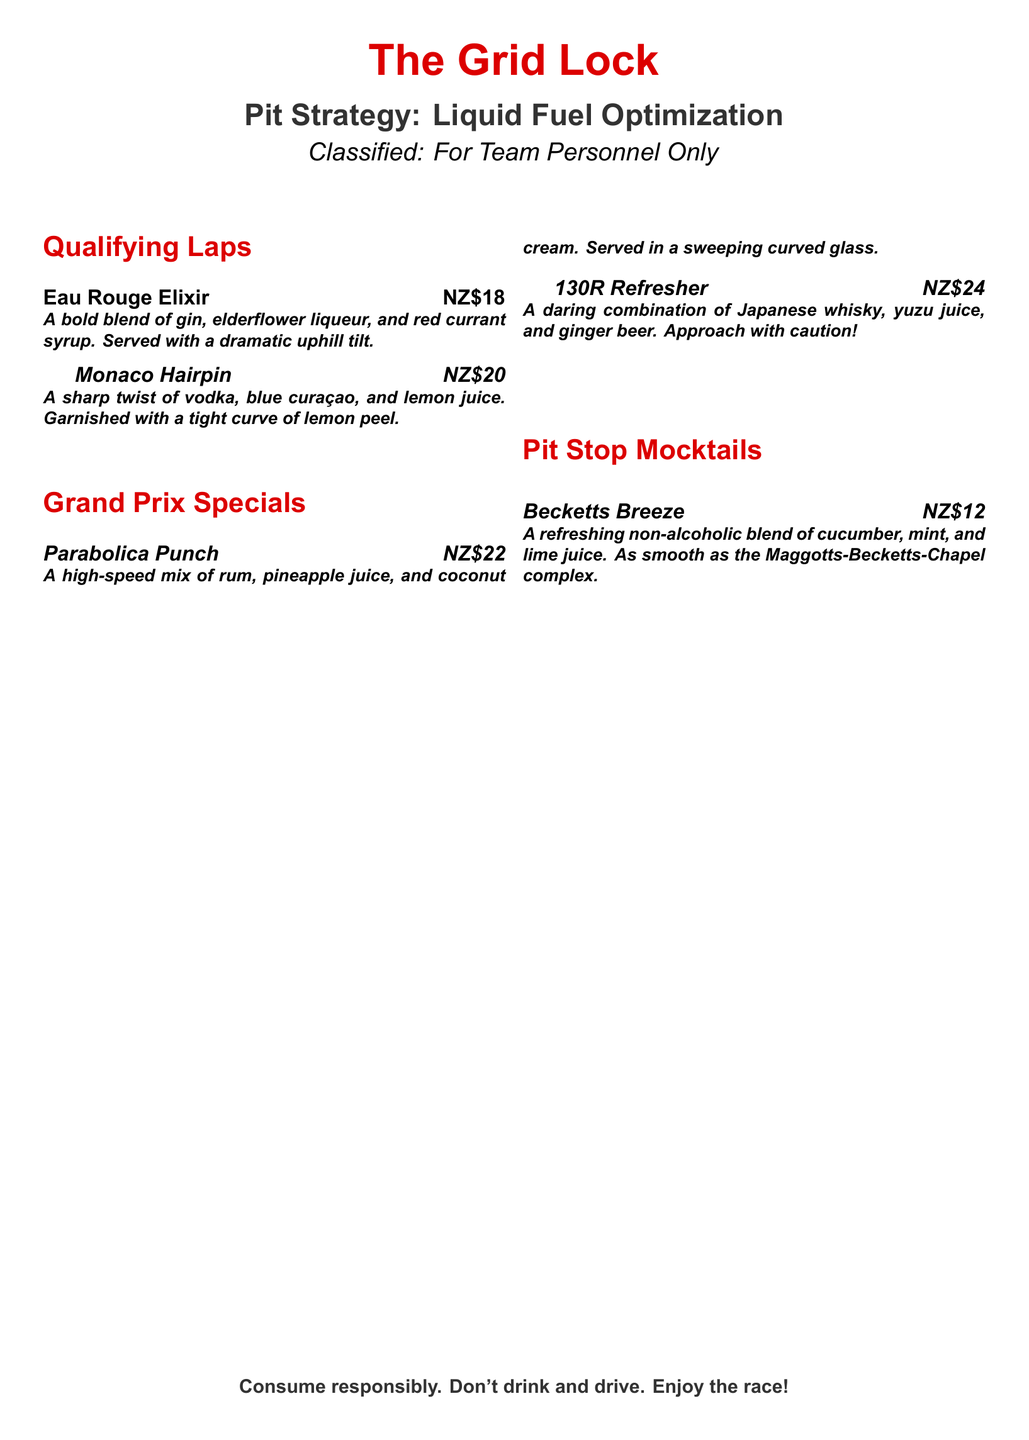What is the name of the first cocktail? The first cocktail listed under 'Qualifying Laps' is named 'Eau Rouge Elixir'.
Answer: Eau Rouge Elixir What is the price of the '130R Refresher'? The document lists the price of the '130R Refresher' under 'Grand Prix Specials' as NZ$24.
Answer: NZ$24 What type of drink is the 'Becketts Breeze'? The 'Becketts Breeze' is classified as a non-alcoholic blend, indicating it is a mocktail.
Answer: Mocktail Which two ingredients are in the 'Monaco Hairpin'? The ingredients of the 'Monaco Hairpin' cocktail include vodka and blue curaçao, as stated in its description.
Answer: Vodka, blue curaçao What section comes after 'Qualifying Laps'? The document lists 'Grand Prix Specials' as the section following 'Qualifying Laps'.
Answer: Grand Prix Specials How much does the 'Parabolica Punch' cost? The price of the 'Parabolica Punch', listed under 'Grand Prix Specials', is NZ$22.
Answer: NZ$22 What is the main alcohol used in the 'Parabolica Punch'? The primary alcohol mentioned in the 'Parabolica Punch' description is rum.
Answer: Rum What flavor is associated with the '130R Refresher'? The '130R Refresher' is noted for its unique flavor, which includes yuzu juice.
Answer: Yuzu juice 